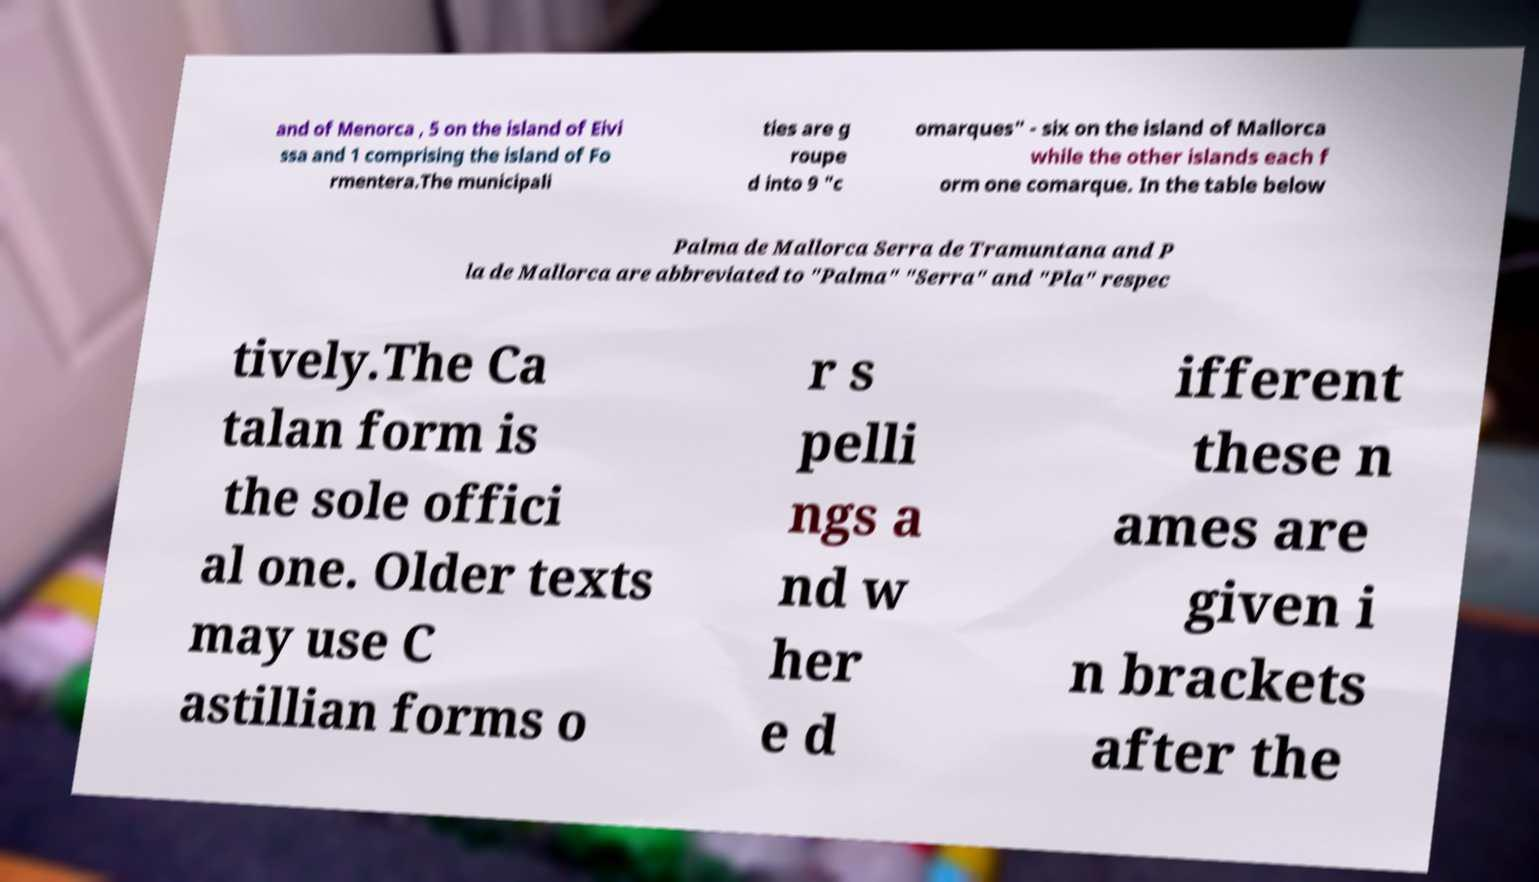For documentation purposes, I need the text within this image transcribed. Could you provide that? and of Menorca , 5 on the island of Eivi ssa and 1 comprising the island of Fo rmentera.The municipali ties are g roupe d into 9 "c omarques" - six on the island of Mallorca while the other islands each f orm one comarque. In the table below Palma de Mallorca Serra de Tramuntana and P la de Mallorca are abbreviated to "Palma" "Serra" and "Pla" respec tively.The Ca talan form is the sole offici al one. Older texts may use C astillian forms o r s pelli ngs a nd w her e d ifferent these n ames are given i n brackets after the 